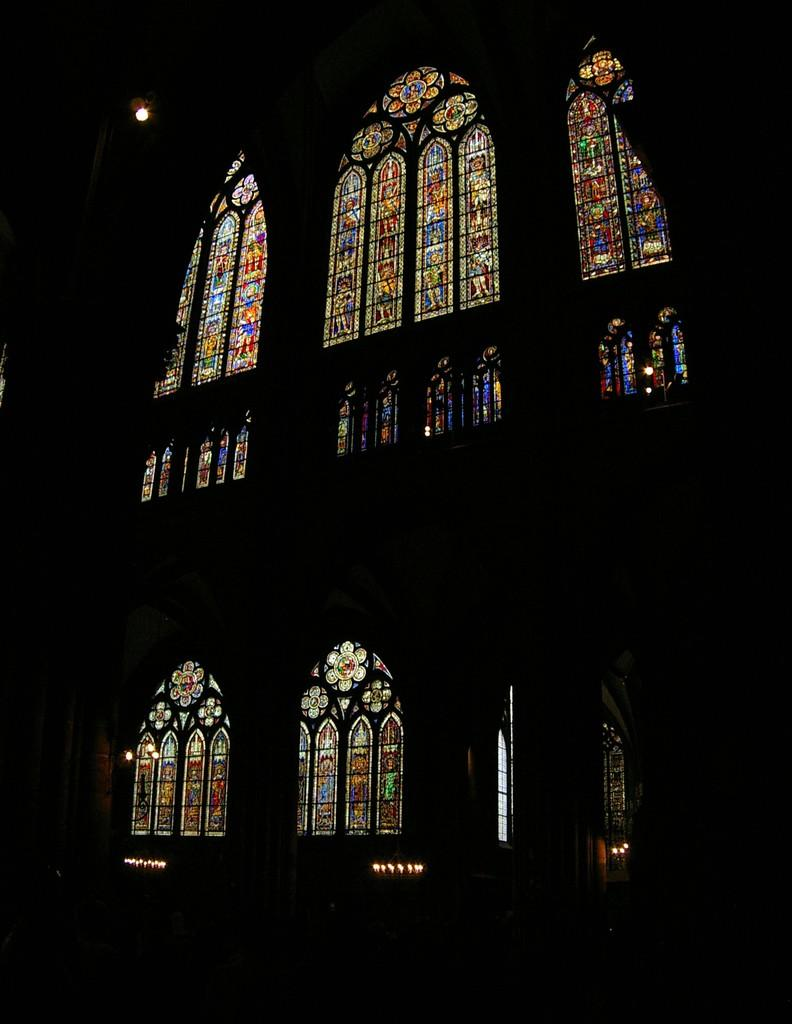What is the overall tone or appearance of the image? The image is dark. What type of artwork is featured in the image? There is a painting on glass in the image. Can you describe the presence of light in the image? Light is visible in the image. How many sticks are being used by the children in the image? There are no children or sticks present in the image. What type of food is being prepared in the image? There is no food preparation or consumption depicted in the image. 